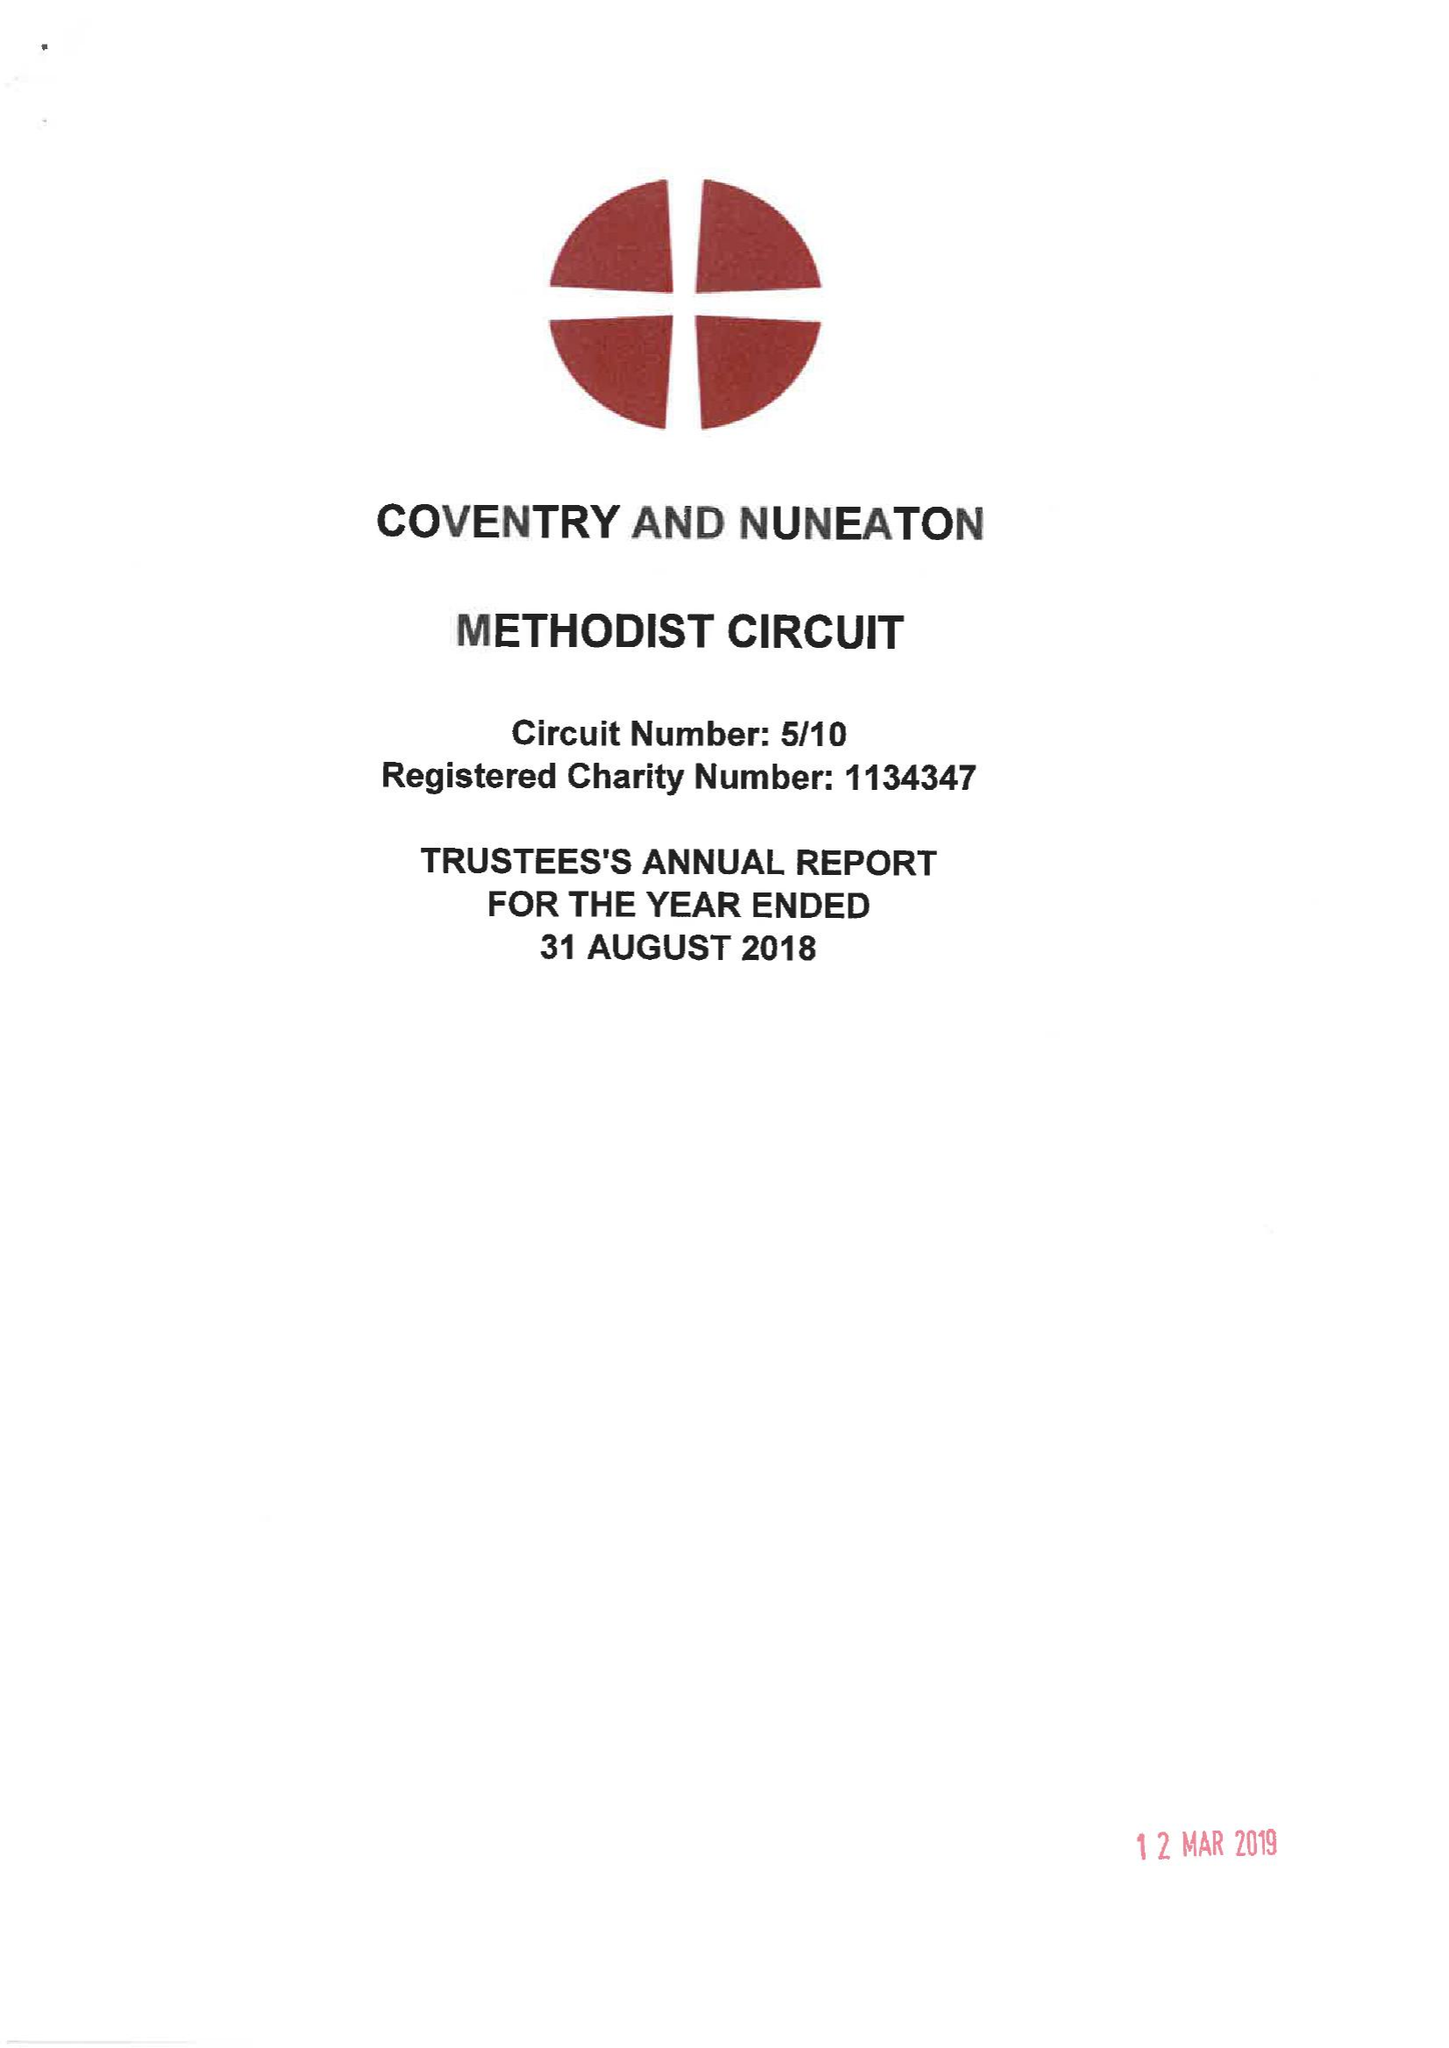What is the value for the address__post_town?
Answer the question using a single word or phrase. COVENTRY 